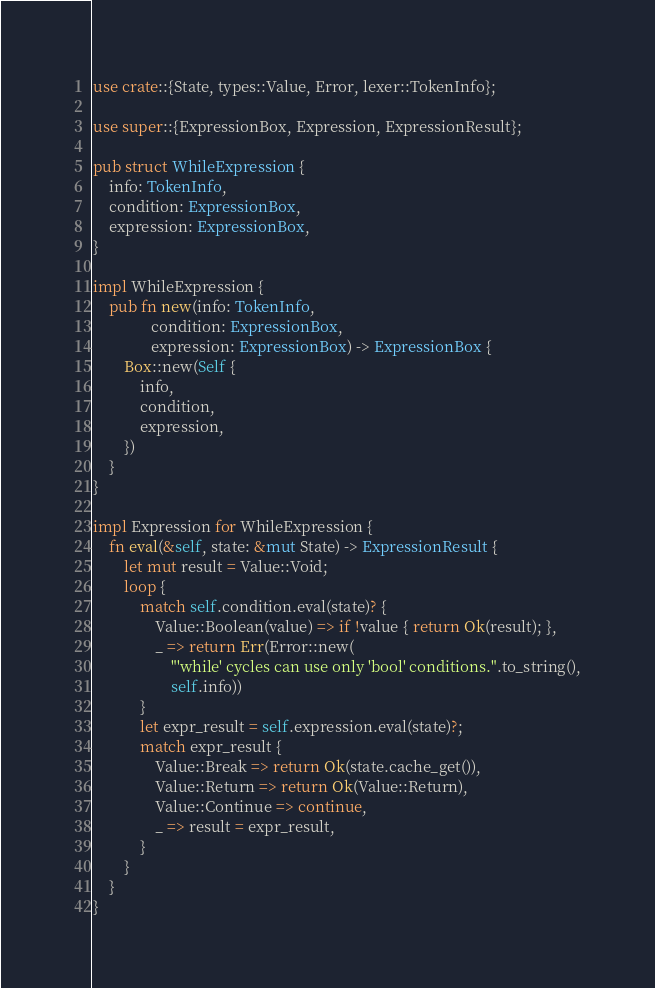<code> <loc_0><loc_0><loc_500><loc_500><_Rust_>use crate::{State, types::Value, Error, lexer::TokenInfo};

use super::{ExpressionBox, Expression, ExpressionResult};

pub struct WhileExpression {
    info: TokenInfo,
    condition: ExpressionBox,
    expression: ExpressionBox,
}

impl WhileExpression {
    pub fn new(info: TokenInfo,
               condition: ExpressionBox,
               expression: ExpressionBox) -> ExpressionBox {
        Box::new(Self {
            info,
            condition,
            expression,
        })
    }
}

impl Expression for WhileExpression {
    fn eval(&self, state: &mut State) -> ExpressionResult {
        let mut result = Value::Void;
        loop {
            match self.condition.eval(state)? {
                Value::Boolean(value) => if !value { return Ok(result); },
                _ => return Err(Error::new(
                    "'while' cycles can use only 'bool' conditions.".to_string(),
                    self.info))
            }
            let expr_result = self.expression.eval(state)?;
            match expr_result {
                Value::Break => return Ok(state.cache_get()),
                Value::Return => return Ok(Value::Return),
                Value::Continue => continue,
                _ => result = expr_result,
            }
        }
    }
}
</code> 